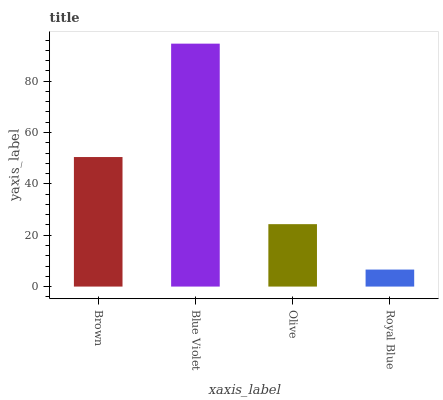Is Royal Blue the minimum?
Answer yes or no. Yes. Is Blue Violet the maximum?
Answer yes or no. Yes. Is Olive the minimum?
Answer yes or no. No. Is Olive the maximum?
Answer yes or no. No. Is Blue Violet greater than Olive?
Answer yes or no. Yes. Is Olive less than Blue Violet?
Answer yes or no. Yes. Is Olive greater than Blue Violet?
Answer yes or no. No. Is Blue Violet less than Olive?
Answer yes or no. No. Is Brown the high median?
Answer yes or no. Yes. Is Olive the low median?
Answer yes or no. Yes. Is Blue Violet the high median?
Answer yes or no. No. Is Blue Violet the low median?
Answer yes or no. No. 